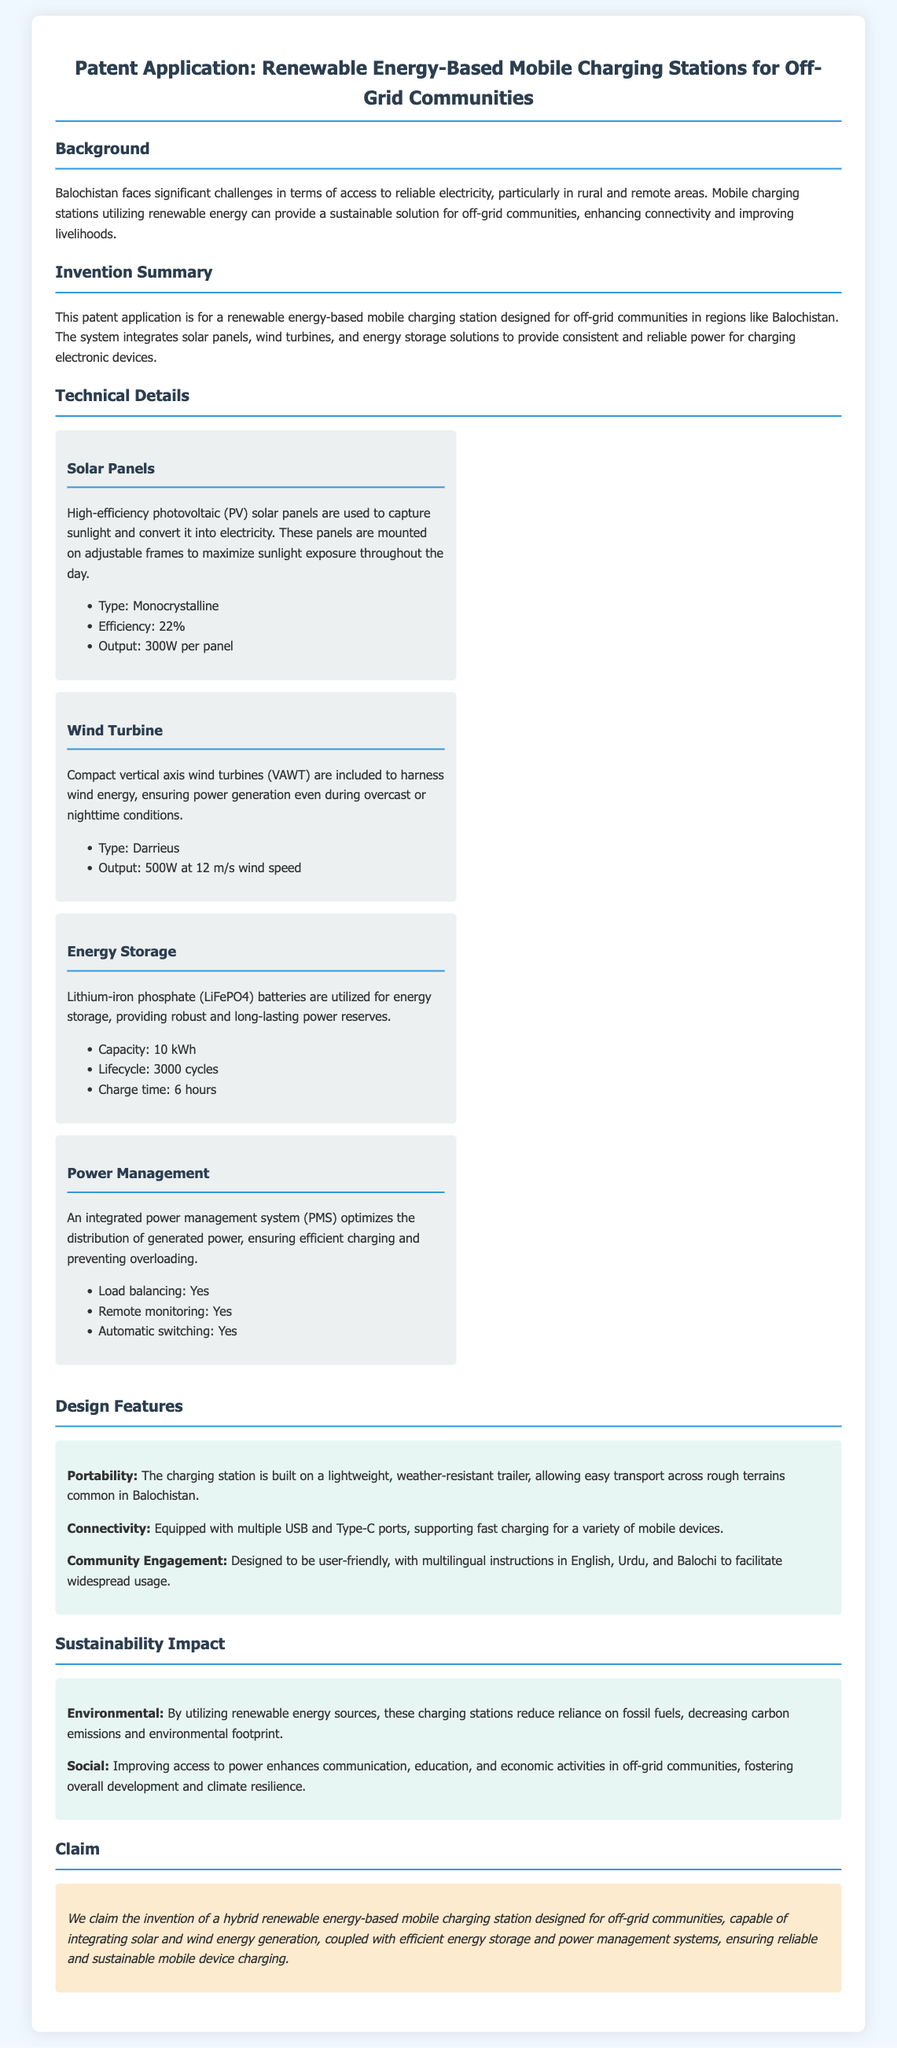what is the title of the patent application? The title of the patent application is stated at the top of the document.
Answer: Renewable Energy-Based Mobile Charging Stations for Off-Grid Communities which renewable energy sources are integrated into the charging station? The document mentions specific types of renewable energy sources utilized in the system.
Answer: Solar panels and wind turbines what is the efficiency of the solar panels? The efficiency of the solar panels is provided in the technical details section of the document.
Answer: 22% what is the output of the wind turbine at 12 m/s wind speed? The output figure for the wind turbine under specific wind conditions is given in the technical item.
Answer: 500W how many cycles can the energy storage batteries provide? The lifecycle of the batteries is mentioned in the technical details section of the document.
Answer: 3000 cycles what unique feature allows the charging station to be easily transported? The design feature that enhances portability is specified in the design section of the document.
Answer: Lightweight, weather-resistant trailer what languages are the instructions available in? The document states the languages included for instructions to support user engagement.
Answer: English, Urdu, and Balochi what is the environmental impact of using renewable energy sources? The sustainability impact section discusses the effects of renewable energy use on the environment.
Answer: Decreasing carbon emissions what does the patent claim focus on? The claim section specifically details the core of the innovation presented in the application.
Answer: Hybrid renewable energy-based mobile charging station 